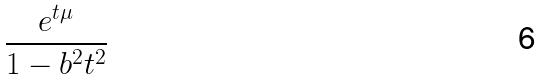Convert formula to latex. <formula><loc_0><loc_0><loc_500><loc_500>\frac { e ^ { t \mu } } { 1 - b ^ { 2 } t ^ { 2 } }</formula> 